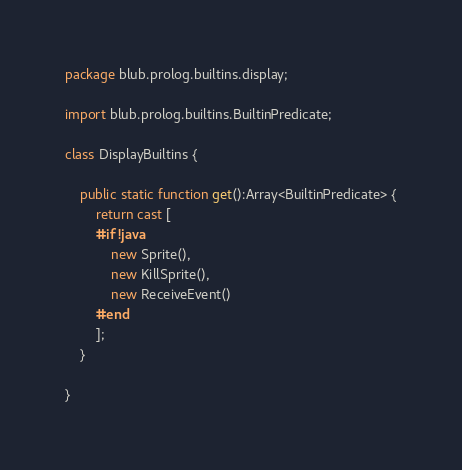Convert code to text. <code><loc_0><loc_0><loc_500><loc_500><_Haxe_>package blub.prolog.builtins.display;

import blub.prolog.builtins.BuiltinPredicate;

class DisplayBuiltins {

    public static function get():Array<BuiltinPredicate> {
        return cast [ 
		#if !java
			new Sprite(),
			new KillSprite(),
			new ReceiveEvent()
		#end               
        ];
    }

}
</code> 